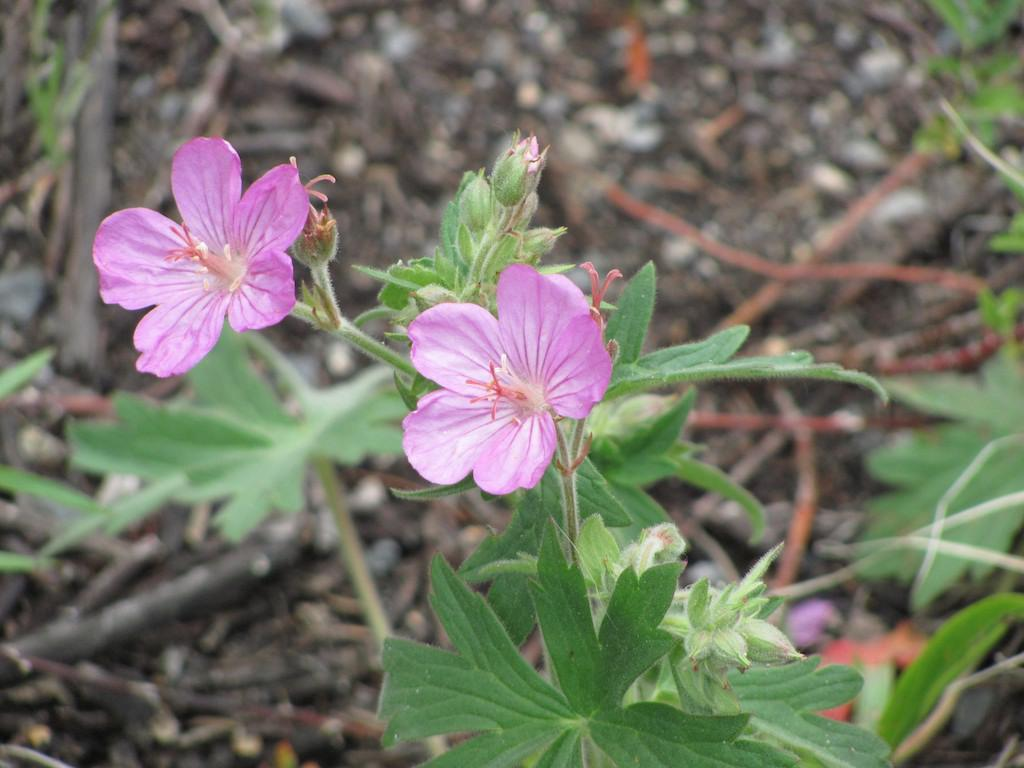What type of flowers are in the foreground of the image? There are two pink flowers in the foreground of the image. Where are the flowers located? The flowers are on a plant. What is the current state of the plant? The plant has buds. What can be seen in the background of the image? There is ground visible in the background of the image, along with additional plants. What type of list can be seen hanging from the heart in the image? There is no list or heart present in the image; it features two pink flowers on a plant with buds and a background of ground and additional plants. 